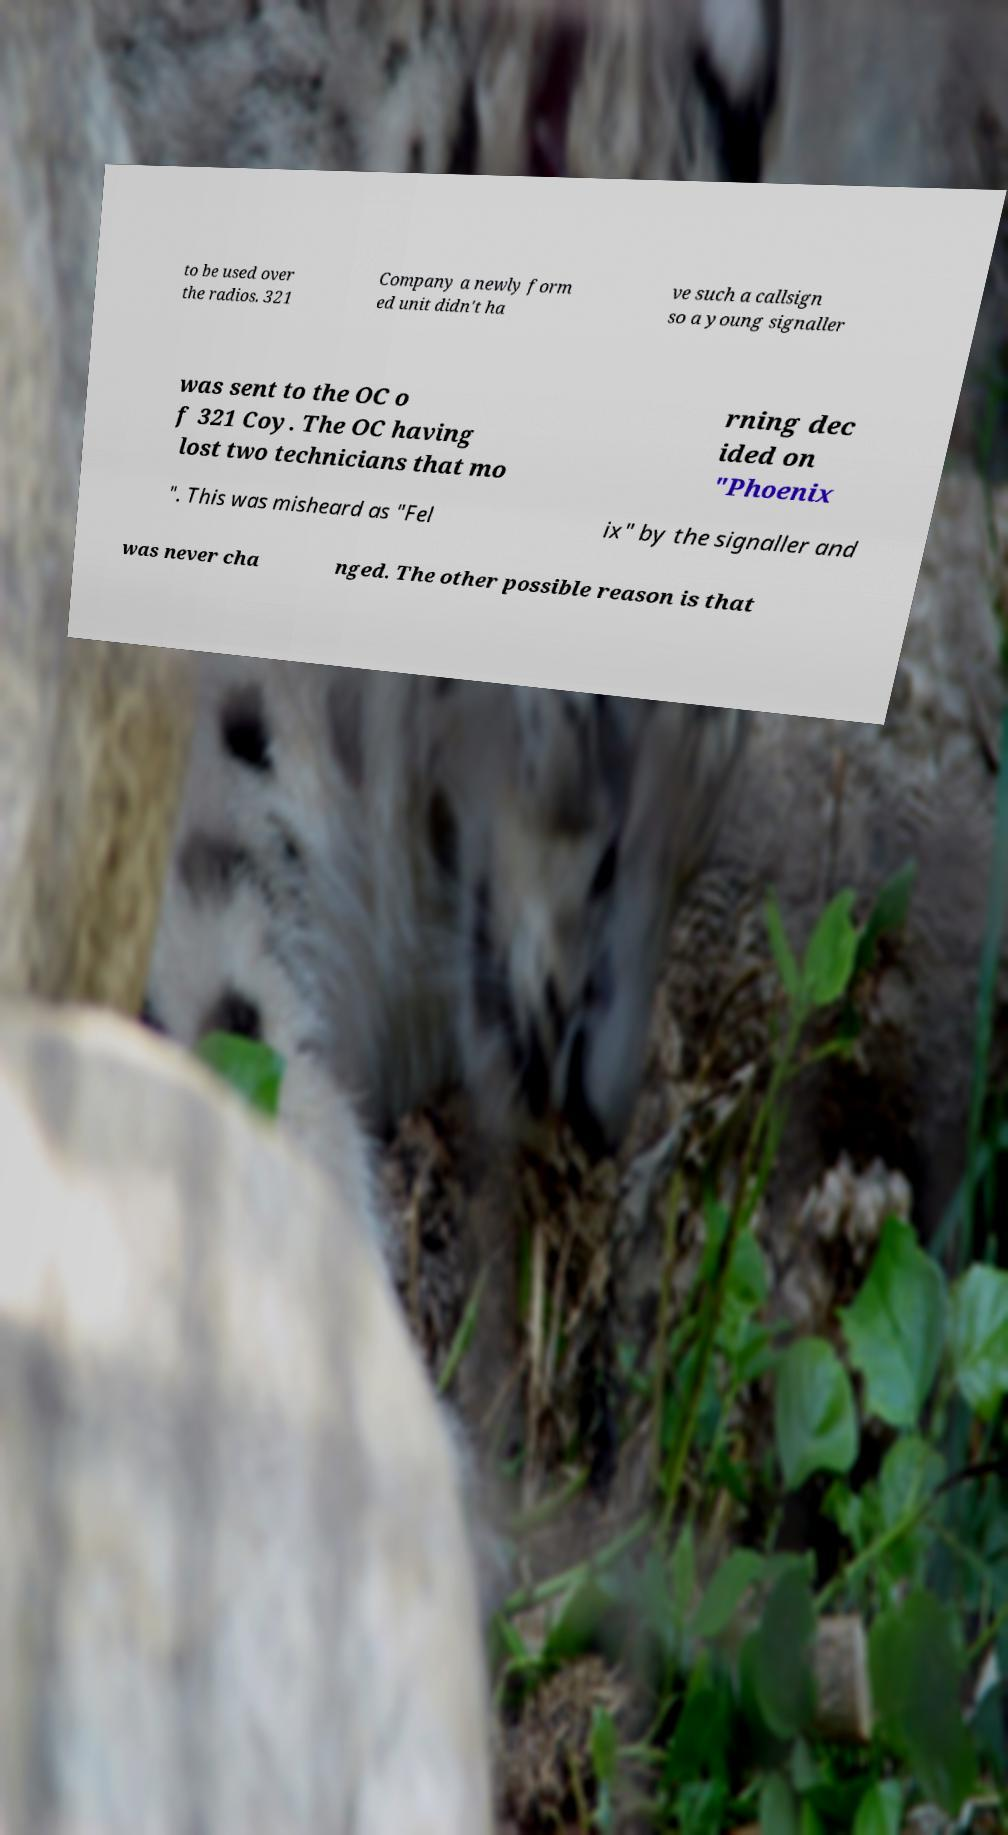Could you assist in decoding the text presented in this image and type it out clearly? to be used over the radios. 321 Company a newly form ed unit didn't ha ve such a callsign so a young signaller was sent to the OC o f 321 Coy. The OC having lost two technicians that mo rning dec ided on "Phoenix ". This was misheard as "Fel ix" by the signaller and was never cha nged. The other possible reason is that 